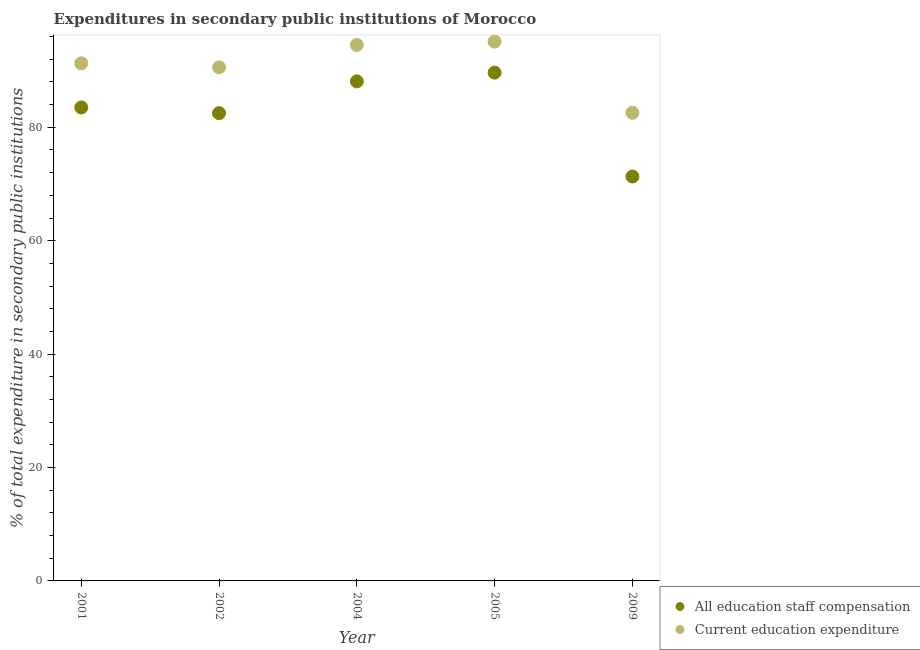How many different coloured dotlines are there?
Give a very brief answer. 2. Is the number of dotlines equal to the number of legend labels?
Provide a succinct answer. Yes. What is the expenditure in staff compensation in 2001?
Make the answer very short. 83.5. Across all years, what is the maximum expenditure in education?
Provide a short and direct response. 95.11. Across all years, what is the minimum expenditure in education?
Ensure brevity in your answer.  82.55. In which year was the expenditure in education maximum?
Make the answer very short. 2005. In which year was the expenditure in education minimum?
Offer a terse response. 2009. What is the total expenditure in education in the graph?
Your response must be concise. 454.05. What is the difference between the expenditure in education in 2001 and that in 2009?
Give a very brief answer. 8.74. What is the difference between the expenditure in staff compensation in 2001 and the expenditure in education in 2009?
Your answer should be very brief. 0.95. What is the average expenditure in education per year?
Make the answer very short. 90.81. In the year 2005, what is the difference between the expenditure in staff compensation and expenditure in education?
Your answer should be very brief. -5.47. In how many years, is the expenditure in education greater than 32 %?
Give a very brief answer. 5. What is the ratio of the expenditure in staff compensation in 2005 to that in 2009?
Your response must be concise. 1.26. Is the difference between the expenditure in education in 2004 and 2009 greater than the difference between the expenditure in staff compensation in 2004 and 2009?
Your answer should be very brief. No. What is the difference between the highest and the second highest expenditure in education?
Your answer should be very brief. 0.58. What is the difference between the highest and the lowest expenditure in staff compensation?
Give a very brief answer. 18.32. Is the expenditure in staff compensation strictly greater than the expenditure in education over the years?
Your answer should be compact. No. How many years are there in the graph?
Give a very brief answer. 5. Where does the legend appear in the graph?
Provide a short and direct response. Bottom right. What is the title of the graph?
Your answer should be compact. Expenditures in secondary public institutions of Morocco. Does "Net savings(excluding particulate emission damage)" appear as one of the legend labels in the graph?
Your response must be concise. No. What is the label or title of the Y-axis?
Offer a terse response. % of total expenditure in secondary public institutions. What is the % of total expenditure in secondary public institutions in All education staff compensation in 2001?
Give a very brief answer. 83.5. What is the % of total expenditure in secondary public institutions in Current education expenditure in 2001?
Provide a succinct answer. 91.29. What is the % of total expenditure in secondary public institutions in All education staff compensation in 2002?
Provide a short and direct response. 82.5. What is the % of total expenditure in secondary public institutions of Current education expenditure in 2002?
Provide a short and direct response. 90.57. What is the % of total expenditure in secondary public institutions in All education staff compensation in 2004?
Provide a succinct answer. 88.1. What is the % of total expenditure in secondary public institutions of Current education expenditure in 2004?
Give a very brief answer. 94.53. What is the % of total expenditure in secondary public institutions in All education staff compensation in 2005?
Give a very brief answer. 89.64. What is the % of total expenditure in secondary public institutions of Current education expenditure in 2005?
Ensure brevity in your answer.  95.11. What is the % of total expenditure in secondary public institutions in All education staff compensation in 2009?
Offer a terse response. 71.32. What is the % of total expenditure in secondary public institutions of Current education expenditure in 2009?
Offer a terse response. 82.55. Across all years, what is the maximum % of total expenditure in secondary public institutions in All education staff compensation?
Keep it short and to the point. 89.64. Across all years, what is the maximum % of total expenditure in secondary public institutions in Current education expenditure?
Make the answer very short. 95.11. Across all years, what is the minimum % of total expenditure in secondary public institutions of All education staff compensation?
Your answer should be very brief. 71.32. Across all years, what is the minimum % of total expenditure in secondary public institutions of Current education expenditure?
Your answer should be very brief. 82.55. What is the total % of total expenditure in secondary public institutions of All education staff compensation in the graph?
Offer a terse response. 415.06. What is the total % of total expenditure in secondary public institutions in Current education expenditure in the graph?
Your answer should be very brief. 454.05. What is the difference between the % of total expenditure in secondary public institutions in Current education expenditure in 2001 and that in 2002?
Your answer should be compact. 0.72. What is the difference between the % of total expenditure in secondary public institutions in All education staff compensation in 2001 and that in 2004?
Give a very brief answer. -4.6. What is the difference between the % of total expenditure in secondary public institutions of Current education expenditure in 2001 and that in 2004?
Ensure brevity in your answer.  -3.24. What is the difference between the % of total expenditure in secondary public institutions of All education staff compensation in 2001 and that in 2005?
Offer a terse response. -6.14. What is the difference between the % of total expenditure in secondary public institutions of Current education expenditure in 2001 and that in 2005?
Offer a terse response. -3.82. What is the difference between the % of total expenditure in secondary public institutions in All education staff compensation in 2001 and that in 2009?
Your answer should be very brief. 12.18. What is the difference between the % of total expenditure in secondary public institutions in Current education expenditure in 2001 and that in 2009?
Make the answer very short. 8.74. What is the difference between the % of total expenditure in secondary public institutions in All education staff compensation in 2002 and that in 2004?
Your answer should be very brief. -5.6. What is the difference between the % of total expenditure in secondary public institutions of Current education expenditure in 2002 and that in 2004?
Offer a terse response. -3.95. What is the difference between the % of total expenditure in secondary public institutions in All education staff compensation in 2002 and that in 2005?
Make the answer very short. -7.14. What is the difference between the % of total expenditure in secondary public institutions of Current education expenditure in 2002 and that in 2005?
Your answer should be very brief. -4.54. What is the difference between the % of total expenditure in secondary public institutions of All education staff compensation in 2002 and that in 2009?
Your answer should be compact. 11.18. What is the difference between the % of total expenditure in secondary public institutions of Current education expenditure in 2002 and that in 2009?
Your response must be concise. 8.02. What is the difference between the % of total expenditure in secondary public institutions in All education staff compensation in 2004 and that in 2005?
Offer a terse response. -1.54. What is the difference between the % of total expenditure in secondary public institutions in Current education expenditure in 2004 and that in 2005?
Offer a terse response. -0.58. What is the difference between the % of total expenditure in secondary public institutions in All education staff compensation in 2004 and that in 2009?
Your answer should be compact. 16.77. What is the difference between the % of total expenditure in secondary public institutions of Current education expenditure in 2004 and that in 2009?
Your answer should be very brief. 11.97. What is the difference between the % of total expenditure in secondary public institutions of All education staff compensation in 2005 and that in 2009?
Give a very brief answer. 18.32. What is the difference between the % of total expenditure in secondary public institutions of Current education expenditure in 2005 and that in 2009?
Ensure brevity in your answer.  12.56. What is the difference between the % of total expenditure in secondary public institutions of All education staff compensation in 2001 and the % of total expenditure in secondary public institutions of Current education expenditure in 2002?
Your response must be concise. -7.07. What is the difference between the % of total expenditure in secondary public institutions of All education staff compensation in 2001 and the % of total expenditure in secondary public institutions of Current education expenditure in 2004?
Give a very brief answer. -11.03. What is the difference between the % of total expenditure in secondary public institutions in All education staff compensation in 2001 and the % of total expenditure in secondary public institutions in Current education expenditure in 2005?
Ensure brevity in your answer.  -11.61. What is the difference between the % of total expenditure in secondary public institutions of All education staff compensation in 2001 and the % of total expenditure in secondary public institutions of Current education expenditure in 2009?
Offer a terse response. 0.95. What is the difference between the % of total expenditure in secondary public institutions of All education staff compensation in 2002 and the % of total expenditure in secondary public institutions of Current education expenditure in 2004?
Make the answer very short. -12.02. What is the difference between the % of total expenditure in secondary public institutions of All education staff compensation in 2002 and the % of total expenditure in secondary public institutions of Current education expenditure in 2005?
Your response must be concise. -12.61. What is the difference between the % of total expenditure in secondary public institutions of All education staff compensation in 2002 and the % of total expenditure in secondary public institutions of Current education expenditure in 2009?
Your answer should be compact. -0.05. What is the difference between the % of total expenditure in secondary public institutions in All education staff compensation in 2004 and the % of total expenditure in secondary public institutions in Current education expenditure in 2005?
Provide a short and direct response. -7.01. What is the difference between the % of total expenditure in secondary public institutions in All education staff compensation in 2004 and the % of total expenditure in secondary public institutions in Current education expenditure in 2009?
Your answer should be very brief. 5.54. What is the difference between the % of total expenditure in secondary public institutions of All education staff compensation in 2005 and the % of total expenditure in secondary public institutions of Current education expenditure in 2009?
Offer a very short reply. 7.09. What is the average % of total expenditure in secondary public institutions of All education staff compensation per year?
Keep it short and to the point. 83.01. What is the average % of total expenditure in secondary public institutions of Current education expenditure per year?
Offer a very short reply. 90.81. In the year 2001, what is the difference between the % of total expenditure in secondary public institutions of All education staff compensation and % of total expenditure in secondary public institutions of Current education expenditure?
Provide a succinct answer. -7.79. In the year 2002, what is the difference between the % of total expenditure in secondary public institutions of All education staff compensation and % of total expenditure in secondary public institutions of Current education expenditure?
Your response must be concise. -8.07. In the year 2004, what is the difference between the % of total expenditure in secondary public institutions of All education staff compensation and % of total expenditure in secondary public institutions of Current education expenditure?
Your answer should be compact. -6.43. In the year 2005, what is the difference between the % of total expenditure in secondary public institutions of All education staff compensation and % of total expenditure in secondary public institutions of Current education expenditure?
Make the answer very short. -5.47. In the year 2009, what is the difference between the % of total expenditure in secondary public institutions of All education staff compensation and % of total expenditure in secondary public institutions of Current education expenditure?
Keep it short and to the point. -11.23. What is the ratio of the % of total expenditure in secondary public institutions of All education staff compensation in 2001 to that in 2002?
Provide a succinct answer. 1.01. What is the ratio of the % of total expenditure in secondary public institutions in Current education expenditure in 2001 to that in 2002?
Your answer should be very brief. 1.01. What is the ratio of the % of total expenditure in secondary public institutions of All education staff compensation in 2001 to that in 2004?
Your response must be concise. 0.95. What is the ratio of the % of total expenditure in secondary public institutions of Current education expenditure in 2001 to that in 2004?
Ensure brevity in your answer.  0.97. What is the ratio of the % of total expenditure in secondary public institutions of All education staff compensation in 2001 to that in 2005?
Your answer should be very brief. 0.93. What is the ratio of the % of total expenditure in secondary public institutions in Current education expenditure in 2001 to that in 2005?
Your answer should be compact. 0.96. What is the ratio of the % of total expenditure in secondary public institutions in All education staff compensation in 2001 to that in 2009?
Offer a terse response. 1.17. What is the ratio of the % of total expenditure in secondary public institutions in Current education expenditure in 2001 to that in 2009?
Give a very brief answer. 1.11. What is the ratio of the % of total expenditure in secondary public institutions in All education staff compensation in 2002 to that in 2004?
Your response must be concise. 0.94. What is the ratio of the % of total expenditure in secondary public institutions in Current education expenditure in 2002 to that in 2004?
Provide a succinct answer. 0.96. What is the ratio of the % of total expenditure in secondary public institutions in All education staff compensation in 2002 to that in 2005?
Keep it short and to the point. 0.92. What is the ratio of the % of total expenditure in secondary public institutions of Current education expenditure in 2002 to that in 2005?
Keep it short and to the point. 0.95. What is the ratio of the % of total expenditure in secondary public institutions in All education staff compensation in 2002 to that in 2009?
Make the answer very short. 1.16. What is the ratio of the % of total expenditure in secondary public institutions in Current education expenditure in 2002 to that in 2009?
Give a very brief answer. 1.1. What is the ratio of the % of total expenditure in secondary public institutions of All education staff compensation in 2004 to that in 2005?
Offer a terse response. 0.98. What is the ratio of the % of total expenditure in secondary public institutions in Current education expenditure in 2004 to that in 2005?
Your response must be concise. 0.99. What is the ratio of the % of total expenditure in secondary public institutions in All education staff compensation in 2004 to that in 2009?
Your answer should be very brief. 1.24. What is the ratio of the % of total expenditure in secondary public institutions of Current education expenditure in 2004 to that in 2009?
Keep it short and to the point. 1.15. What is the ratio of the % of total expenditure in secondary public institutions in All education staff compensation in 2005 to that in 2009?
Your answer should be very brief. 1.26. What is the ratio of the % of total expenditure in secondary public institutions of Current education expenditure in 2005 to that in 2009?
Offer a terse response. 1.15. What is the difference between the highest and the second highest % of total expenditure in secondary public institutions of All education staff compensation?
Your response must be concise. 1.54. What is the difference between the highest and the second highest % of total expenditure in secondary public institutions in Current education expenditure?
Your answer should be compact. 0.58. What is the difference between the highest and the lowest % of total expenditure in secondary public institutions in All education staff compensation?
Provide a short and direct response. 18.32. What is the difference between the highest and the lowest % of total expenditure in secondary public institutions in Current education expenditure?
Your response must be concise. 12.56. 